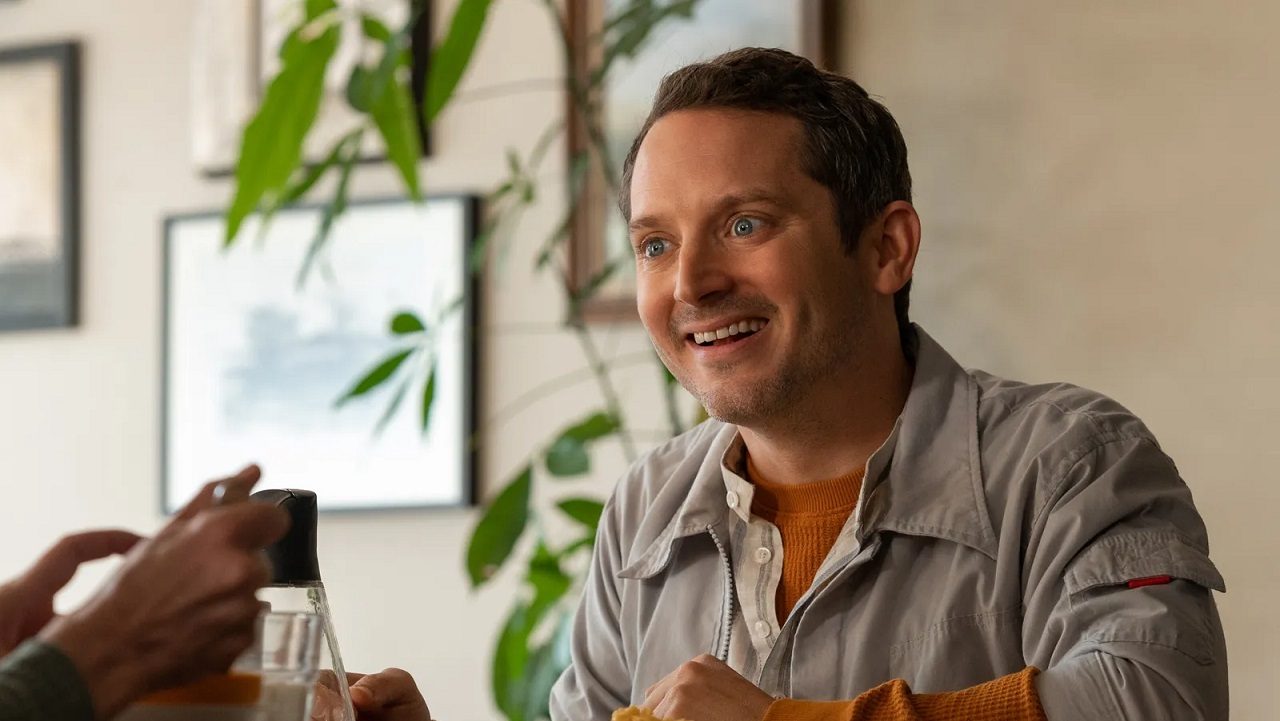Write a detailed description of the given image. In the image, we see an individual enjoying a moment of relaxation in what appears to be a cozy and casual restaurant setting. The person is seated at a table and dressed in a light gray jacket over an orange sweater, exuding a laid-back style. He appears to be engaged in a pleasant conversation, as indicated by his bright smile and the attentive look directed towards someone off-camera. On the table, there are various objects, including a glass bottle within the hands of another person, suggesting a shared experience or convivial moment. Plants in the background add a touch of nature to the indoor setting, contributing to a relaxed and inviting atmosphere. Through the slightly blurred window, one can also glimpse a building outside, placing the scene within an urban context. 